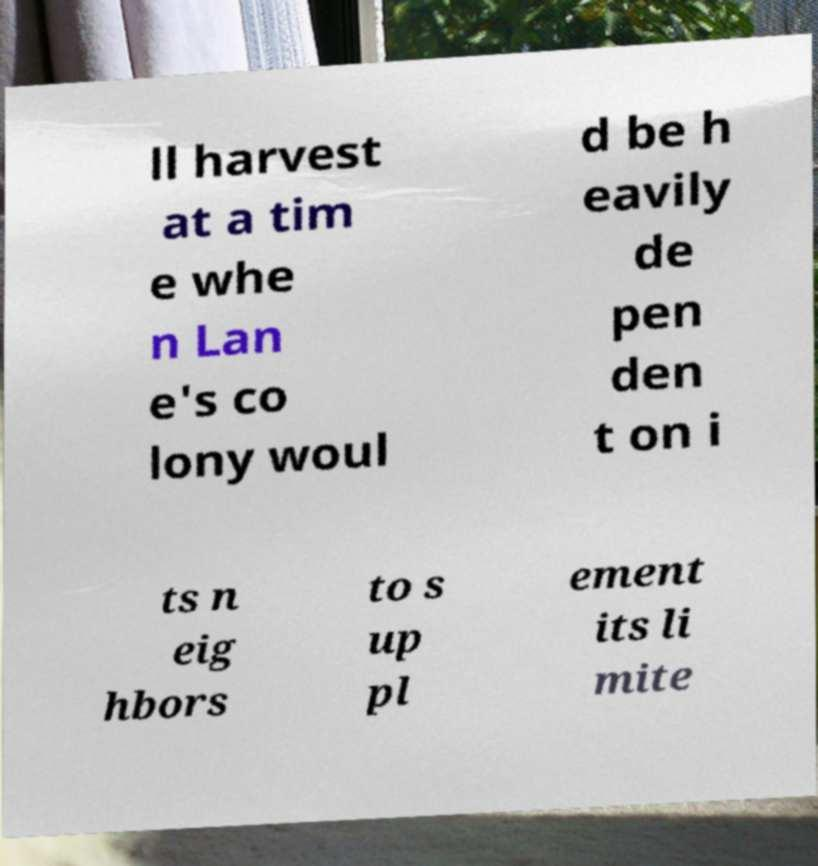I need the written content from this picture converted into text. Can you do that? ll harvest at a tim e whe n Lan e's co lony woul d be h eavily de pen den t on i ts n eig hbors to s up pl ement its li mite 